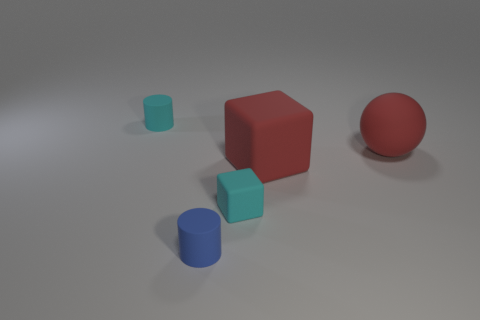Add 1 small shiny cylinders. How many objects exist? 6 Subtract all blocks. How many objects are left? 3 Add 5 small green objects. How many small green objects exist? 5 Subtract 1 blue cylinders. How many objects are left? 4 Subtract all spheres. Subtract all spheres. How many objects are left? 3 Add 4 large red cubes. How many large red cubes are left? 5 